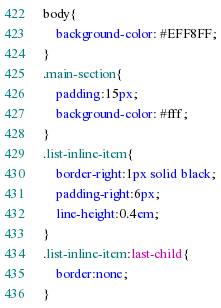<code> <loc_0><loc_0><loc_500><loc_500><_CSS_>body{
	background-color: #EFF8FF;
}
.main-section{
	padding:15px;
	background-color: #fff;
}
.list-inline-item{
	border-right:1px solid black;
	padding-right:6px;
	line-height:0.4em;
}
.list-inline-item:last-child{
	border:none;
}
</code> 